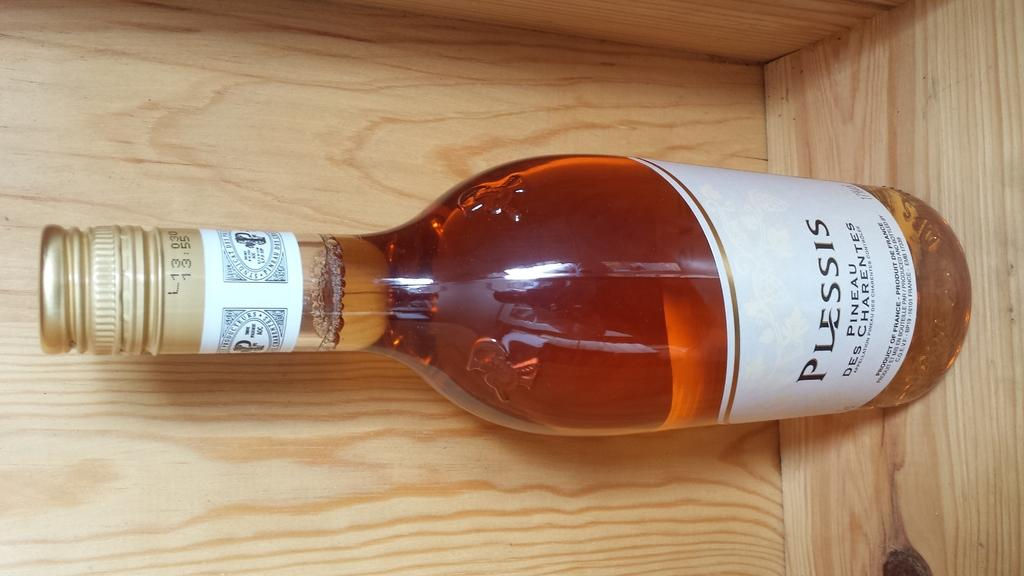<image>
Render a clear and concise summary of the photo. An un-open bottle of Plessis Pineau Des Charentes is sitting on a shelf. 